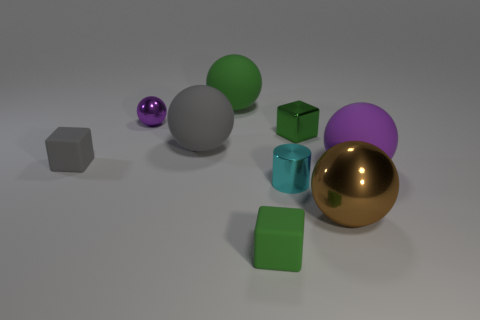What materials could these objects represent in a real-world setting? The objects in the image appear to represent various materials. The shiny gold and purple spheres could be metallic, the transparent cyan object could be made of glass or plastic, while the matte green cubes and gray hexahedron might represent opaque plastics or painted wood. Could you tell me how light interacts with these materials differently? Certainly! The metallic spheres reflect light smoothly and clearly, indicating a glossy and reflective surface, which is characteristic of metals. The transparent object allows light to pass through with minimal distortion, a property of clear glass or certain plastics. The matte objects diffuse light, spreading it evenly across their surfaces, which results in less glare and a softer appearance. 